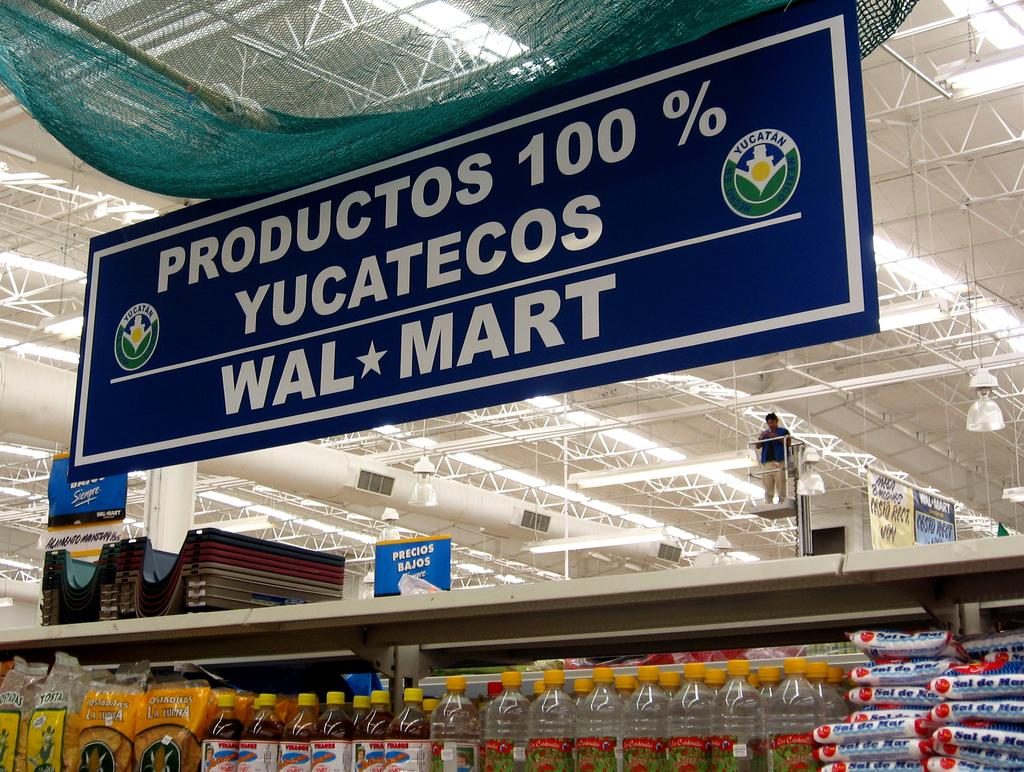<image>
Create a compact narrative representing the image presented. Productos 100% Yucatecos sign hangs above a shelf of items. 